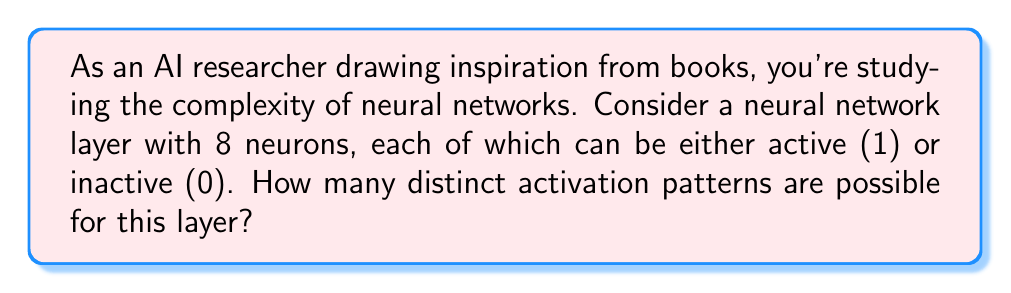Could you help me with this problem? To solve this problem, we need to understand the following concepts:

1. Each neuron in the layer can be in one of two states: active (1) or inactive (0).
2. We need to count all possible combinations of these states across all 8 neurons.

This is a perfect scenario for using the multiplication principle of counting. Here's how we can approach it:

1. For each neuron, we have 2 choices (0 or 1).
2. We have 8 neurons in total.
3. For each choice of the first neuron, we have 2 choices for the second, 2 for the third, and so on.

Therefore, the total number of distinct activation patterns is:

$$ 2 \times 2 \times 2 \times 2 \times 2 \times 2 \times 2 \times 2 = 2^8 $$

We can also think of this as a binary number with 8 digits, where each digit represents a neuron's state. The number of possible 8-digit binary numbers is $2^8$.

Calculating $2^8$:

$$ 2^8 = 2 \times 2 \times 2 \times 2 \times 2 \times 2 \times 2 \times 2 = 256 $$

This result shows that even a relatively small layer of 8 neurons can produce a large number of distinct activation patterns, which contributes to the complexity and expressiveness of neural networks.
Answer: $256$ distinct activation patterns 